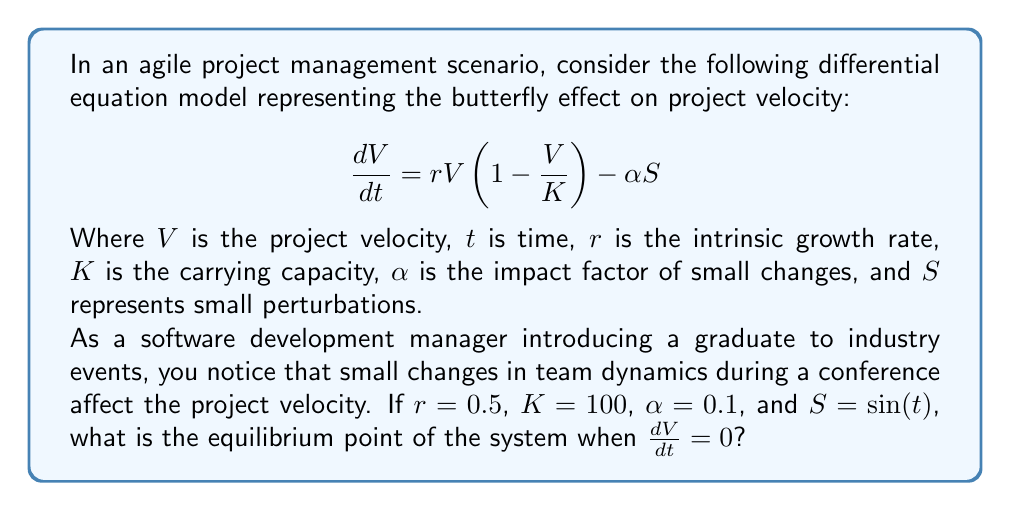Can you solve this math problem? To find the equilibrium point, we need to set $\frac{dV}{dt} = 0$ and solve for $V$:

1) Set the equation to zero:
   $$0 = rV(1 - \frac{V}{K}) - \alpha S$$

2) Substitute the given values:
   $$0 = 0.5V(1 - \frac{V}{100}) - 0.1\sin(t)$$

3) Expand the equation:
   $$0 = 0.5V - 0.005V^2 - 0.1\sin(t)$$

4) To find the equilibrium point, we need to consider the average effect of the sine function over time, which is zero. So, we can simplify the equation to:
   $$0 = 0.5V - 0.005V^2$$

5) Factor out $V$:
   $$V(0.5 - 0.005V) = 0$$

6) Solve for $V$:
   $V = 0$ or $0.5 - 0.005V = 0$
   
   From the second equation:
   $0.5 = 0.005V$
   $V = 100$

7) The equilibrium points are $V = 0$ and $V = 100$. However, $V = 0$ represents a trivial solution (no project velocity), so the non-trivial equilibrium point is $V = 100$.
Answer: $V = 100$ 